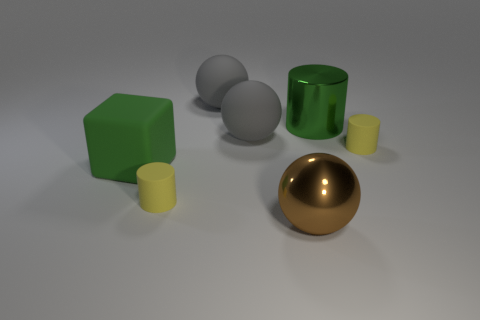What shape is the big brown thing that is the same material as the green cylinder?
Offer a very short reply. Sphere. There is a metallic thing behind the large matte cube; is its size the same as the shiny thing in front of the block?
Offer a terse response. Yes. There is a metallic object that is to the right of the metal sphere; what color is it?
Offer a terse response. Green. There is a large ball that is in front of the gray thing that is in front of the metallic cylinder; what is its material?
Keep it short and to the point. Metal. The green rubber thing has what shape?
Make the answer very short. Cube. How many other metallic balls are the same size as the brown sphere?
Ensure brevity in your answer.  0. Are there any tiny yellow matte objects in front of the tiny matte cylinder that is to the right of the brown thing?
Offer a very short reply. Yes. How many purple things are either tiny things or small matte blocks?
Offer a terse response. 0. The rubber cube is what color?
Offer a very short reply. Green. What is the size of the green object that is made of the same material as the brown object?
Provide a short and direct response. Large. 